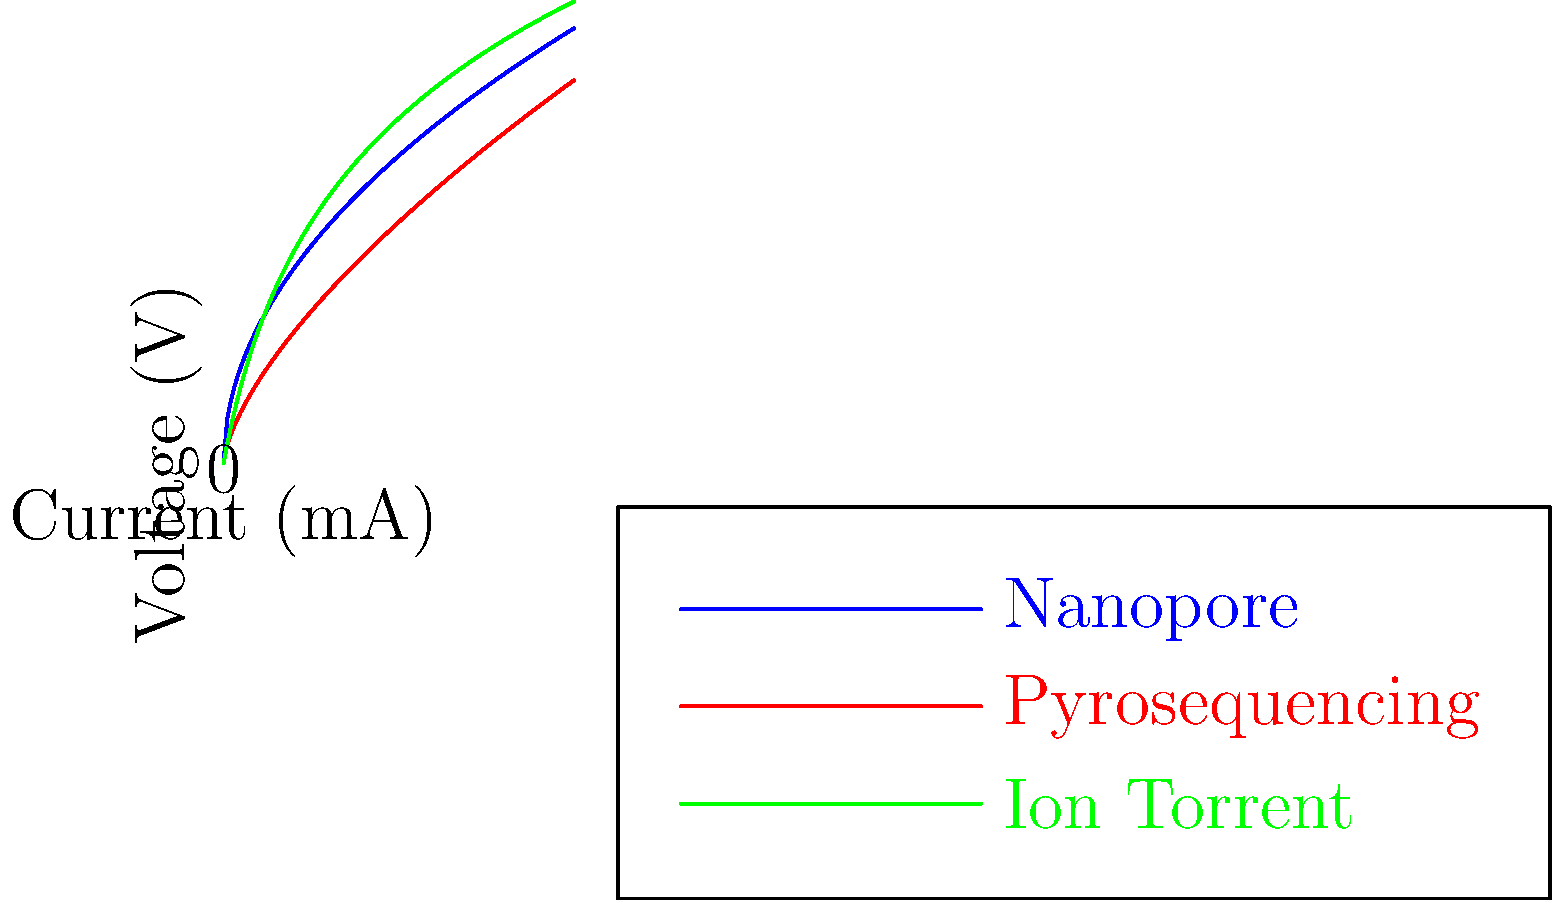Based on the voltage-current characteristics shown in the graph for different DNA sequencing techniques, which method exhibits the highest voltage sensitivity at low current levels? To determine which DNA sequencing technique has the highest voltage sensitivity at low current levels, we need to analyze the slope of each curve near the origin (0,0). A steeper slope indicates higher voltage sensitivity.

Step 1: Examine the curves near the origin.
- Nanopore (blue): Starts with a steep slope that gradually decreases.
- Pyrosequencing (red): Begins with a relatively flat slope that increases.
- Ion Torrent (green): Has the steepest initial slope that quickly flattens out.

Step 2: Compare the initial slopes.
The Ion Torrent curve (green) has the steepest initial slope, indicating the highest rate of voltage change per unit of current at low current levels.

Step 3: Understand the implications.
A steeper slope at low current levels means that small changes in current result in larger changes in voltage. This translates to higher sensitivity in detecting small variations in the DNA sequence.

Step 4: Consider the technology.
Ion Torrent sequencing detects small pH changes caused by the release of hydrogen ions during DNA synthesis. This explains its high sensitivity at low current levels, as even small ionic changes can produce significant voltage differences.
Answer: Ion Torrent 